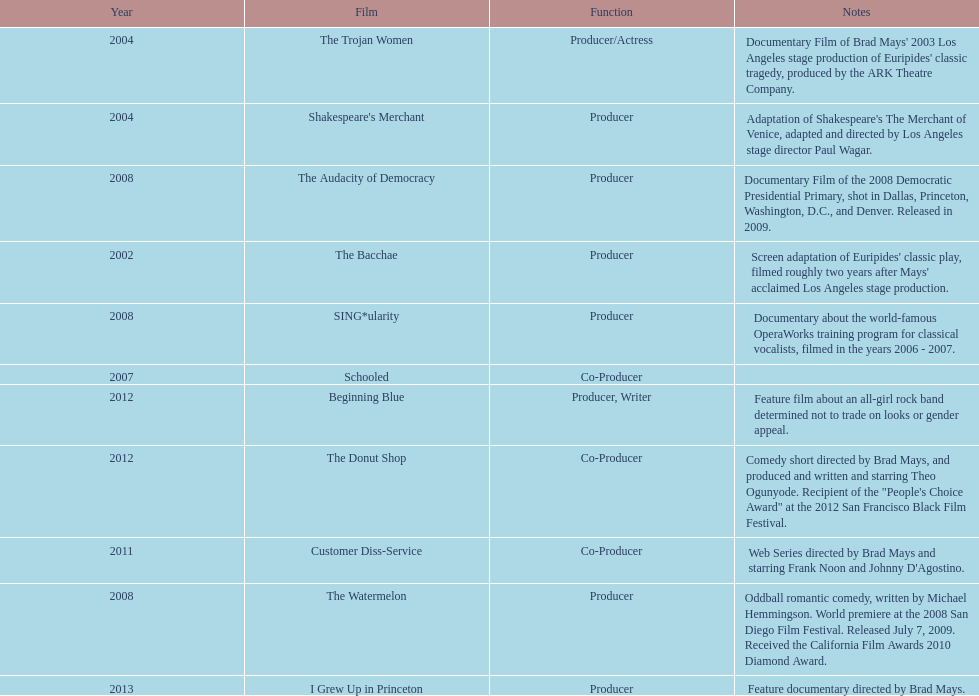Who was the initial producer responsible for creating the movie sing*ularity? Lorenda Starfelt. 